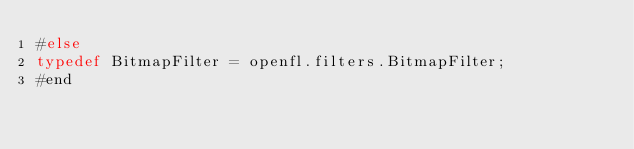<code> <loc_0><loc_0><loc_500><loc_500><_Haxe_>#else
typedef BitmapFilter = openfl.filters.BitmapFilter;
#end
</code> 